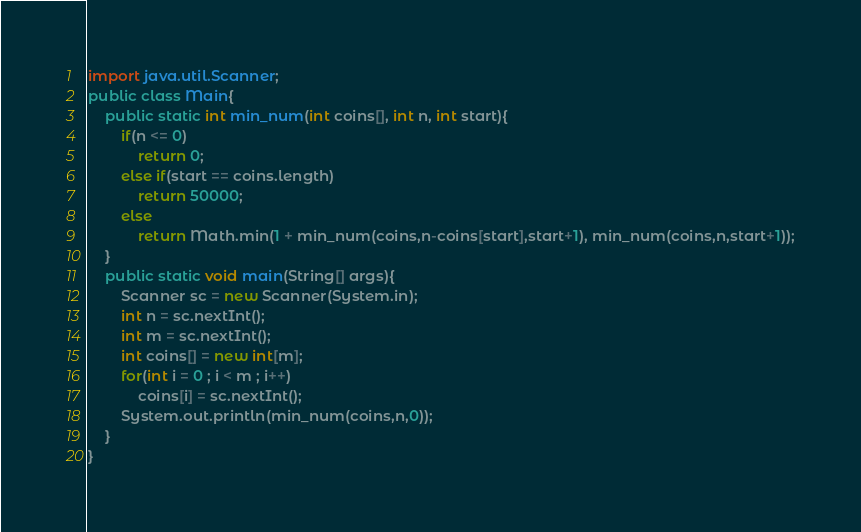Convert code to text. <code><loc_0><loc_0><loc_500><loc_500><_Java_>import java.util.Scanner;
public class Main{
    public static int min_num(int coins[], int n, int start){
        if(n <= 0)
            return 0;
        else if(start == coins.length)
            return 50000;
        else
            return Math.min(1 + min_num(coins,n-coins[start],start+1), min_num(coins,n,start+1));
    }
    public static void main(String[] args){
        Scanner sc = new Scanner(System.in);
        int n = sc.nextInt();
        int m = sc.nextInt();
        int coins[] = new int[m];
        for(int i = 0 ; i < m ; i++)
            coins[i] = sc.nextInt();
        System.out.println(min_num(coins,n,0));
    }
}
</code> 